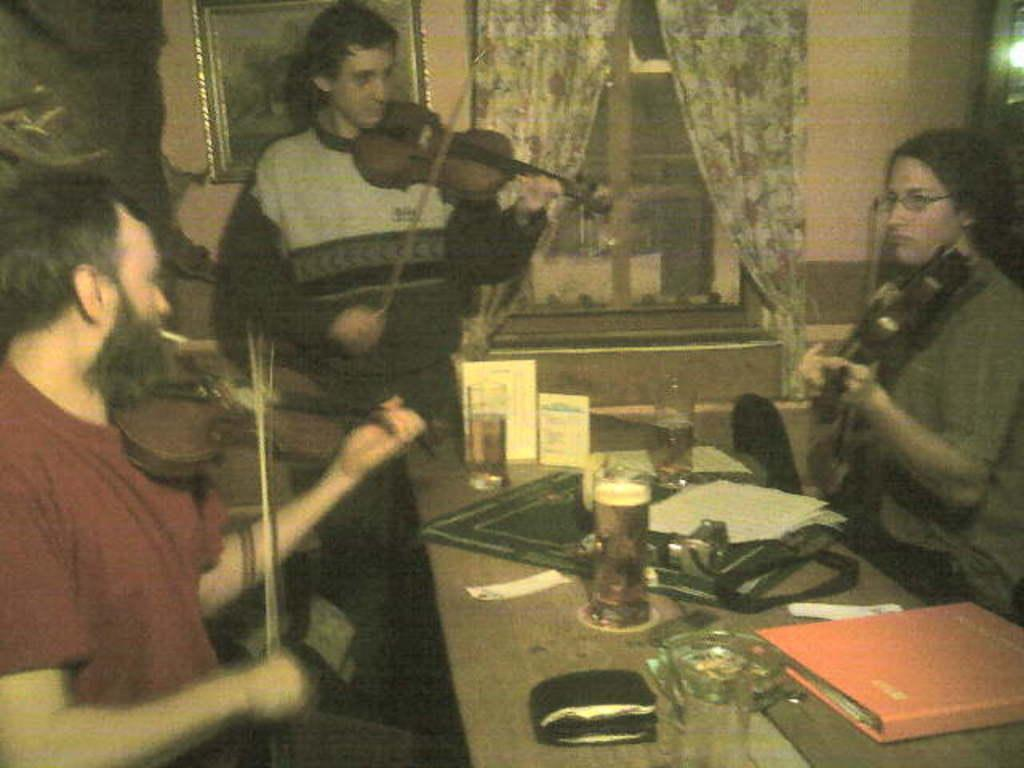What type of structure can be seen in the image? There is a wall in the image. What feature is present in the wall? There is a window in the image. What is covering the window? There are curtains in the image. What is hanging on the wall? There is a photo frame in the image. How many people are in the image? There are three people in the image. What are the people holding? The people are holding guitars. What piece of furniture is in the image? There is a table in the image. What is on the table? There is a book, a glass, a wallet, and papers on the table. How are the pies distributed among the people in the image? There are no pies present in the image. What type of cable is connected to the guitar in the image? There is no cable connected to the guitar in the image; the people are simply holding the guitars. 